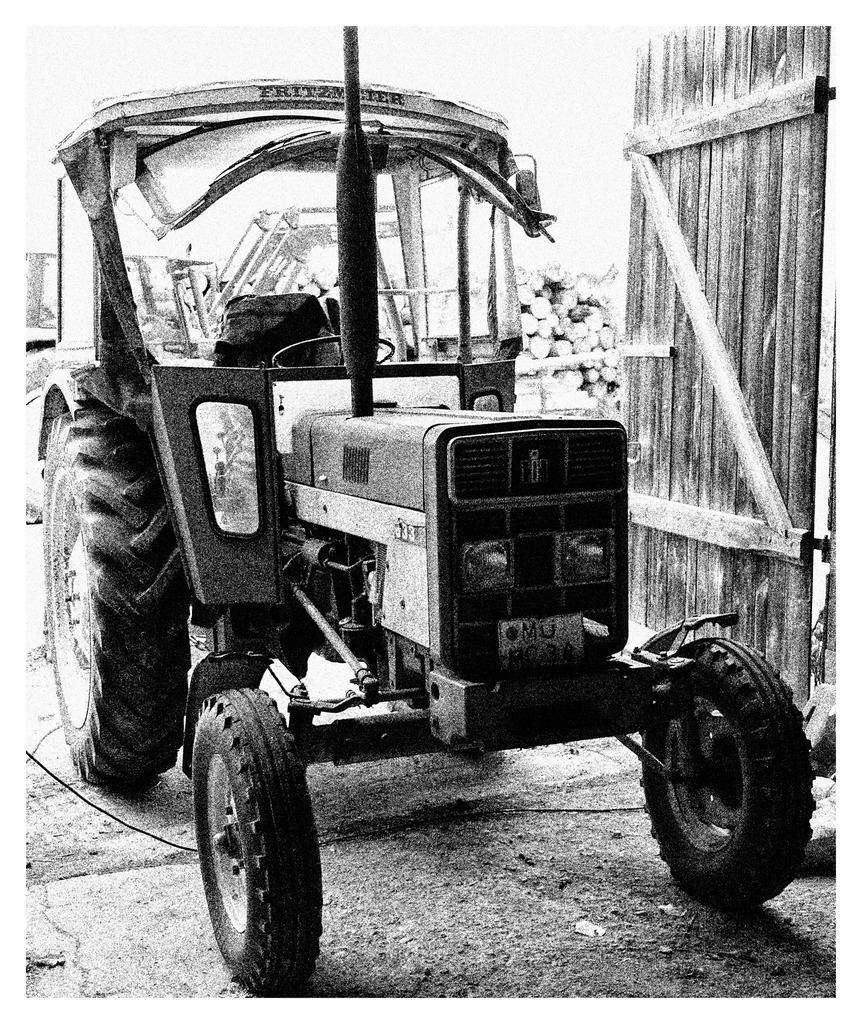What is located on the ground in the image? There is a vehicle on the ground in the image. What type of objects can be seen besides the vehicle? Wooden sticks are visible in the image. What can be seen in the background of the image? There are tree trunks in the background of the image. Reasoning: Let' Let's think step by step in order to produce the conversation. We start by identifying the main subject in the image, which is the vehicle on the ground. Then, we expand the conversation to include other objects that are also visible, such as the wooden sticks. Finally, we describe the background of the image, which features tree trunks. Each question is designed to elicit a specific detail about the image that is known from the provided facts. Absurd Question/Answer: What type of cake is being served in the lunchroom in the image? There is no lunchroom or cake present in the image. What season is depicted in the image? The provided facts do not mention any seasonal elements, so it cannot be determined from the image. 